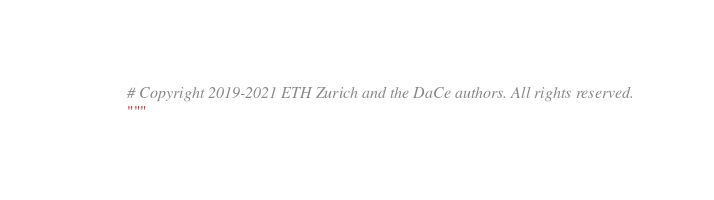Convert code to text. <code><loc_0><loc_0><loc_500><loc_500><_Python_># Copyright 2019-2021 ETH Zurich and the DaCe authors. All rights reserved.
""" </code> 